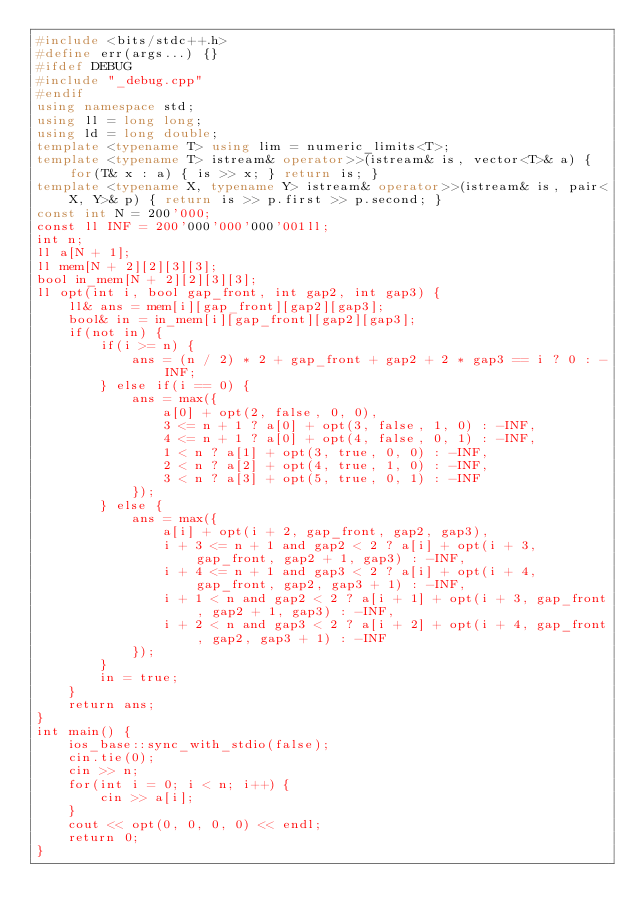<code> <loc_0><loc_0><loc_500><loc_500><_C++_>#include <bits/stdc++.h>
#define err(args...) {}
#ifdef DEBUG
#include "_debug.cpp"
#endif
using namespace std;
using ll = long long;
using ld = long double;
template <typename T> using lim = numeric_limits<T>;
template <typename T> istream& operator>>(istream& is, vector<T>& a) { for(T& x : a) { is >> x; } return is; }
template <typename X, typename Y> istream& operator>>(istream& is, pair<X, Y>& p) { return is >> p.first >> p.second; }
const int N = 200'000;
const ll INF = 200'000'000'000'001ll;
int n;
ll a[N + 1];
ll mem[N + 2][2][3][3];
bool in_mem[N + 2][2][3][3];
ll opt(int i, bool gap_front, int gap2, int gap3) {
    ll& ans = mem[i][gap_front][gap2][gap3];
    bool& in = in_mem[i][gap_front][gap2][gap3];
    if(not in) {
        if(i >= n) {
            ans = (n / 2) * 2 + gap_front + gap2 + 2 * gap3 == i ? 0 : -INF;
        } else if(i == 0) {
            ans = max({
                a[0] + opt(2, false, 0, 0),
                3 <= n + 1 ? a[0] + opt(3, false, 1, 0) : -INF,
                4 <= n + 1 ? a[0] + opt(4, false, 0, 1) : -INF,
                1 < n ? a[1] + opt(3, true, 0, 0) : -INF,
                2 < n ? a[2] + opt(4, true, 1, 0) : -INF,
                3 < n ? a[3] + opt(5, true, 0, 1) : -INF
            });
        } else {
            ans = max({
                a[i] + opt(i + 2, gap_front, gap2, gap3),
                i + 3 <= n + 1 and gap2 < 2 ? a[i] + opt(i + 3, gap_front, gap2 + 1, gap3) : -INF,
                i + 4 <= n + 1 and gap3 < 2 ? a[i] + opt(i + 4, gap_front, gap2, gap3 + 1) : -INF,
                i + 1 < n and gap2 < 2 ? a[i + 1] + opt(i + 3, gap_front, gap2 + 1, gap3) : -INF,
                i + 2 < n and gap3 < 2 ? a[i + 2] + opt(i + 4, gap_front, gap2, gap3 + 1) : -INF
            });
        }
        in = true;
    }
    return ans;
}
int main() {
    ios_base::sync_with_stdio(false);
    cin.tie(0);
    cin >> n;
    for(int i = 0; i < n; i++) {
        cin >> a[i];
    }
    cout << opt(0, 0, 0, 0) << endl;
    return 0;
}
</code> 